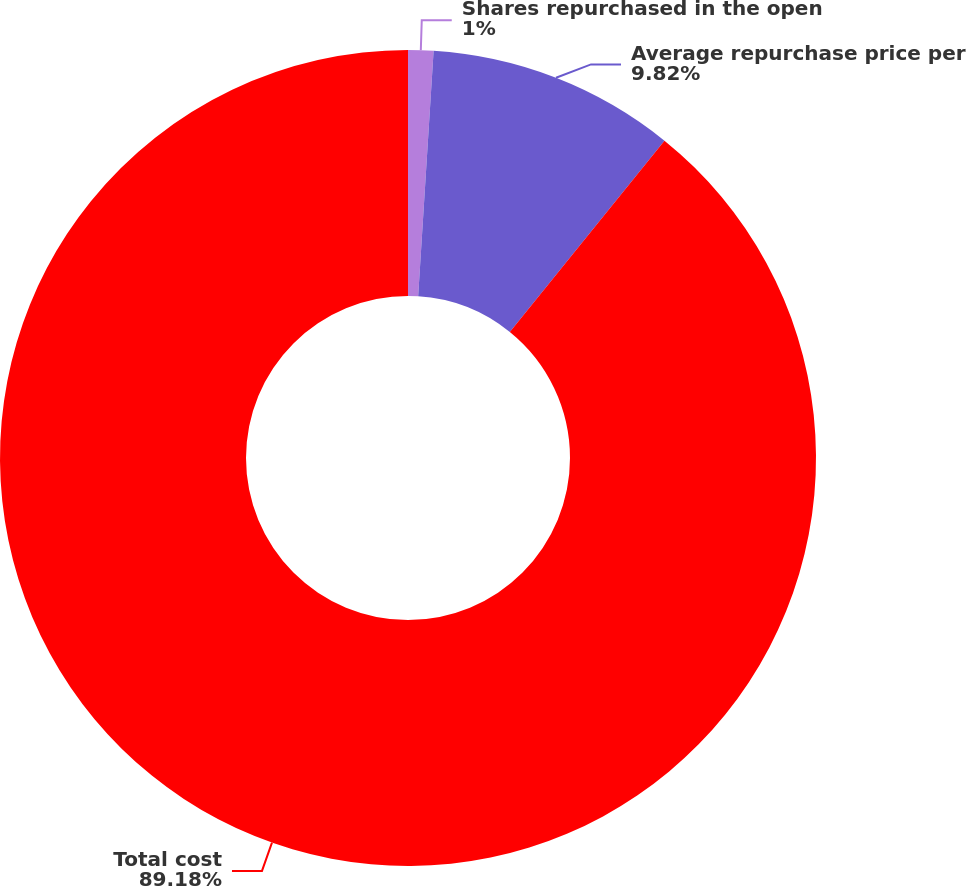<chart> <loc_0><loc_0><loc_500><loc_500><pie_chart><fcel>Shares repurchased in the open<fcel>Average repurchase price per<fcel>Total cost<nl><fcel>1.0%<fcel>9.82%<fcel>89.19%<nl></chart> 